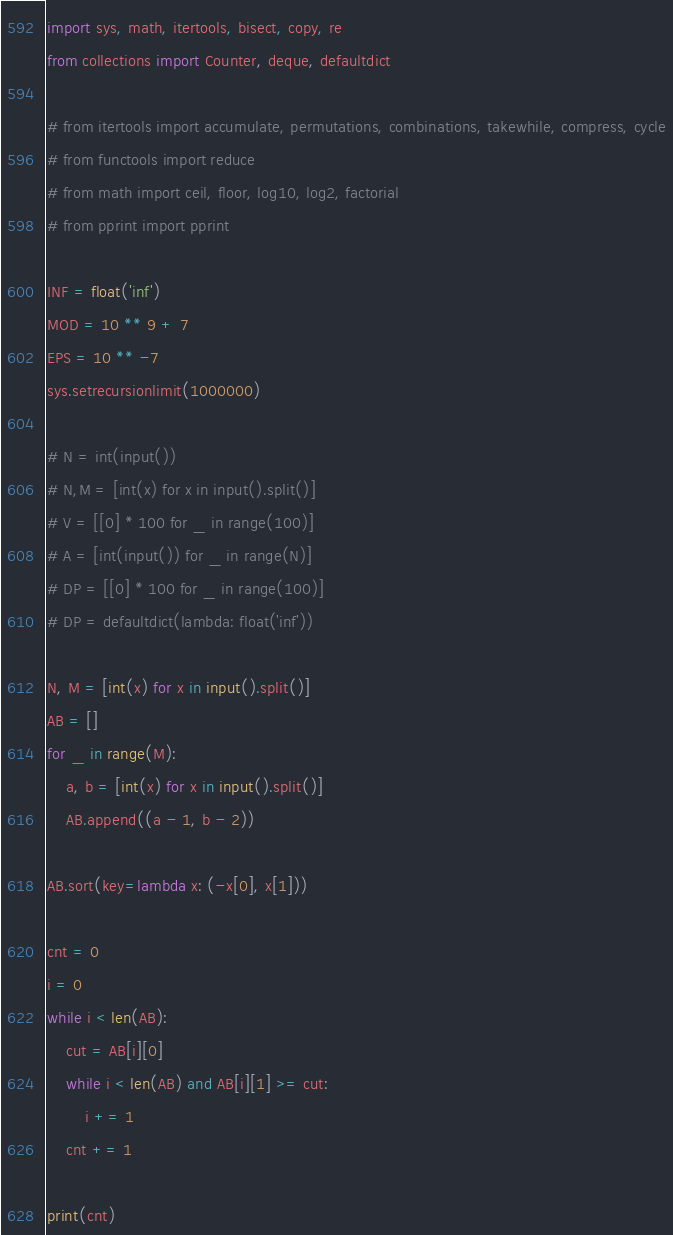Convert code to text. <code><loc_0><loc_0><loc_500><loc_500><_Python_>import sys, math, itertools, bisect, copy, re
from collections import Counter, deque, defaultdict

# from itertools import accumulate, permutations, combinations, takewhile, compress, cycle
# from functools import reduce
# from math import ceil, floor, log10, log2, factorial
# from pprint import pprint

INF = float('inf')
MOD = 10 ** 9 + 7
EPS = 10 ** -7
sys.setrecursionlimit(1000000)

# N = int(input())
# N,M = [int(x) for x in input().split()]
# V = [[0] * 100 for _ in range(100)]
# A = [int(input()) for _ in range(N)]
# DP = [[0] * 100 for _ in range(100)]
# DP = defaultdict(lambda: float('inf'))

N, M = [int(x) for x in input().split()]
AB = []
for _ in range(M):
    a, b = [int(x) for x in input().split()]
    AB.append((a - 1, b - 2))

AB.sort(key=lambda x: (-x[0], x[1]))

cnt = 0
i = 0
while i < len(AB):
    cut = AB[i][0]
    while i < len(AB) and AB[i][1] >= cut:
        i += 1
    cnt += 1

print(cnt)
</code> 